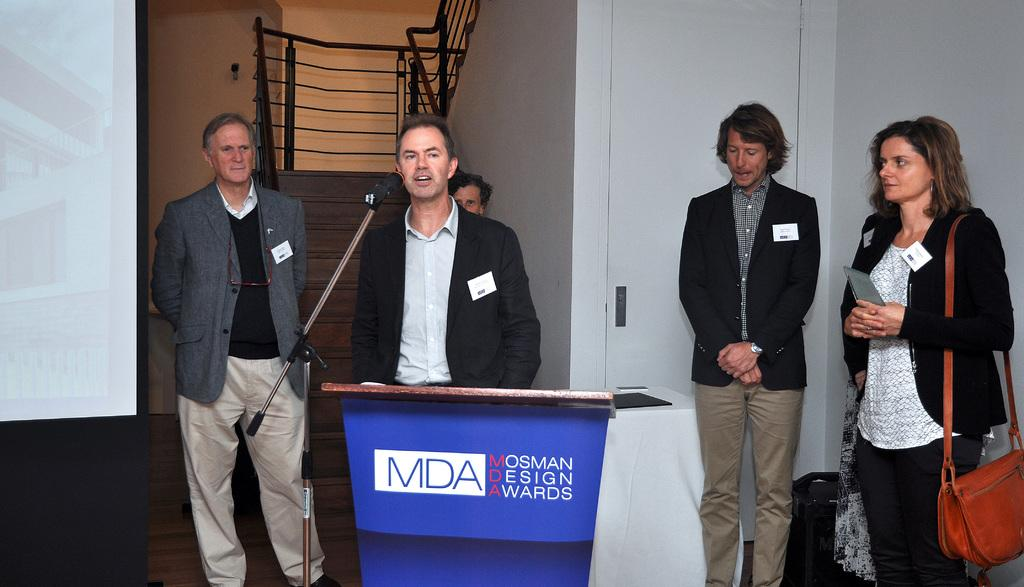What is the general activity of the people in the image? There are people standing in the image, which suggests they might be attending an event or gathering. Can you describe the man near the podium? There is a man standing near a podium, which indicates he might be a speaker or presenter. What is the purpose of the microphone in the image? The microphone (mike) in the image is likely used for amplifying the speaker's voice during the event. What architectural features can be seen in the background of the image? There are stairs and walls in the background of the image. What type of paper is being used to build the stairs in the image? There is no paper being used to build the stairs in the image; the stairs are made of a solid material, such as concrete or wood. 